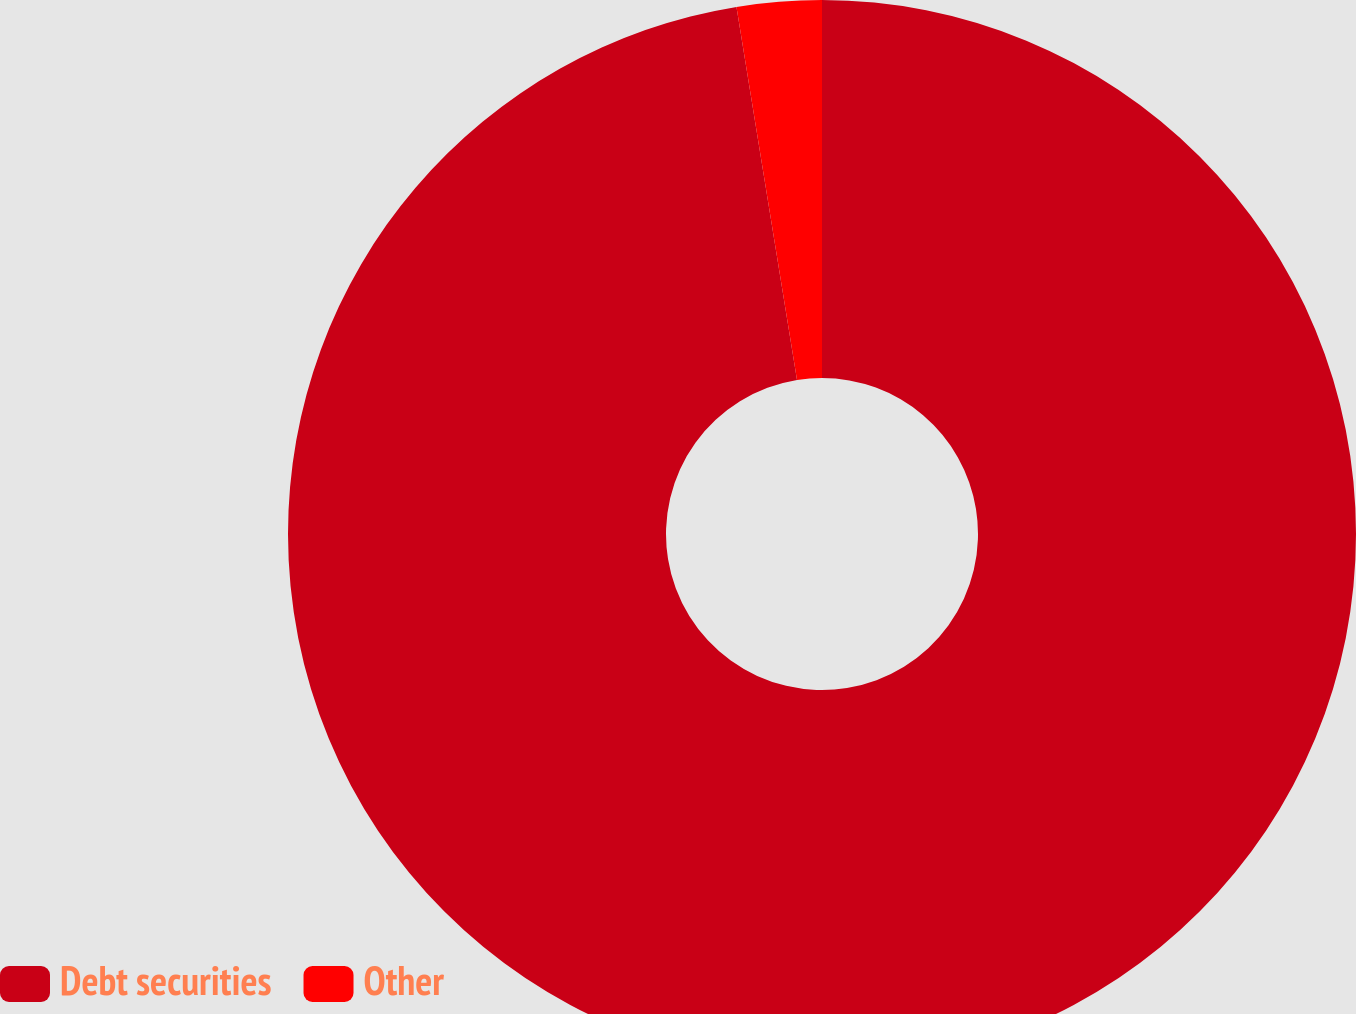Convert chart to OTSL. <chart><loc_0><loc_0><loc_500><loc_500><pie_chart><fcel>Debt securities<fcel>Other<nl><fcel>97.44%<fcel>2.56%<nl></chart> 